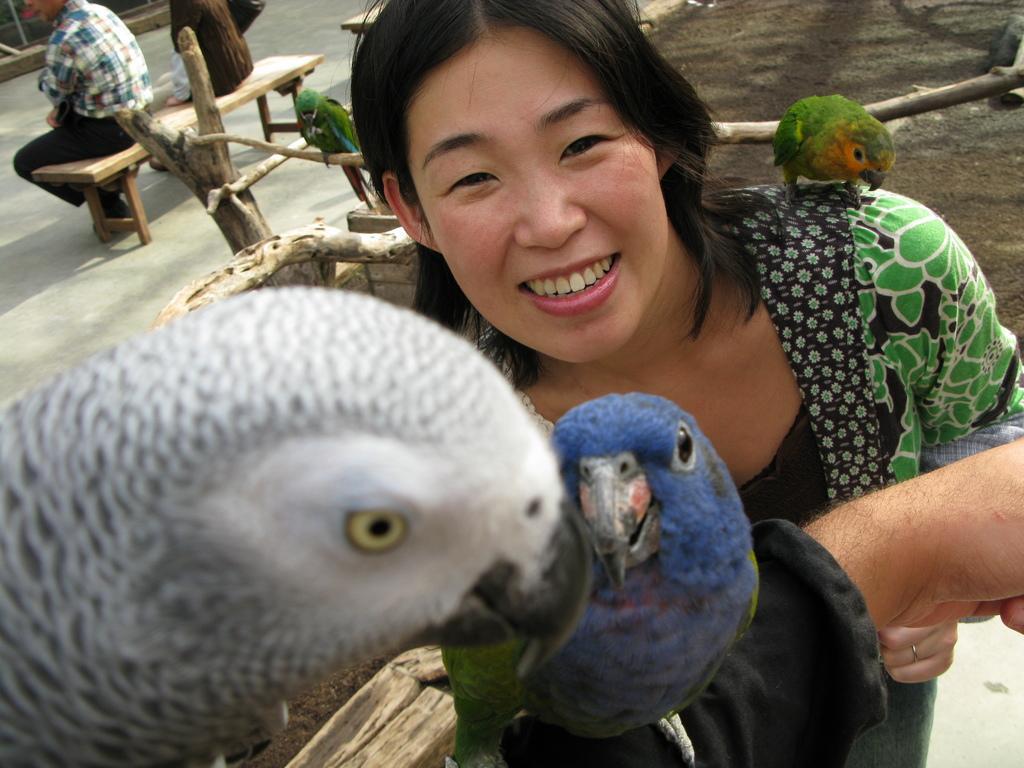Describe this image in one or two sentences. In this image we can see a few birds and also we can see the three persons, among them, two persons are sitting on the bench, there is a tree trunk and some wood. 